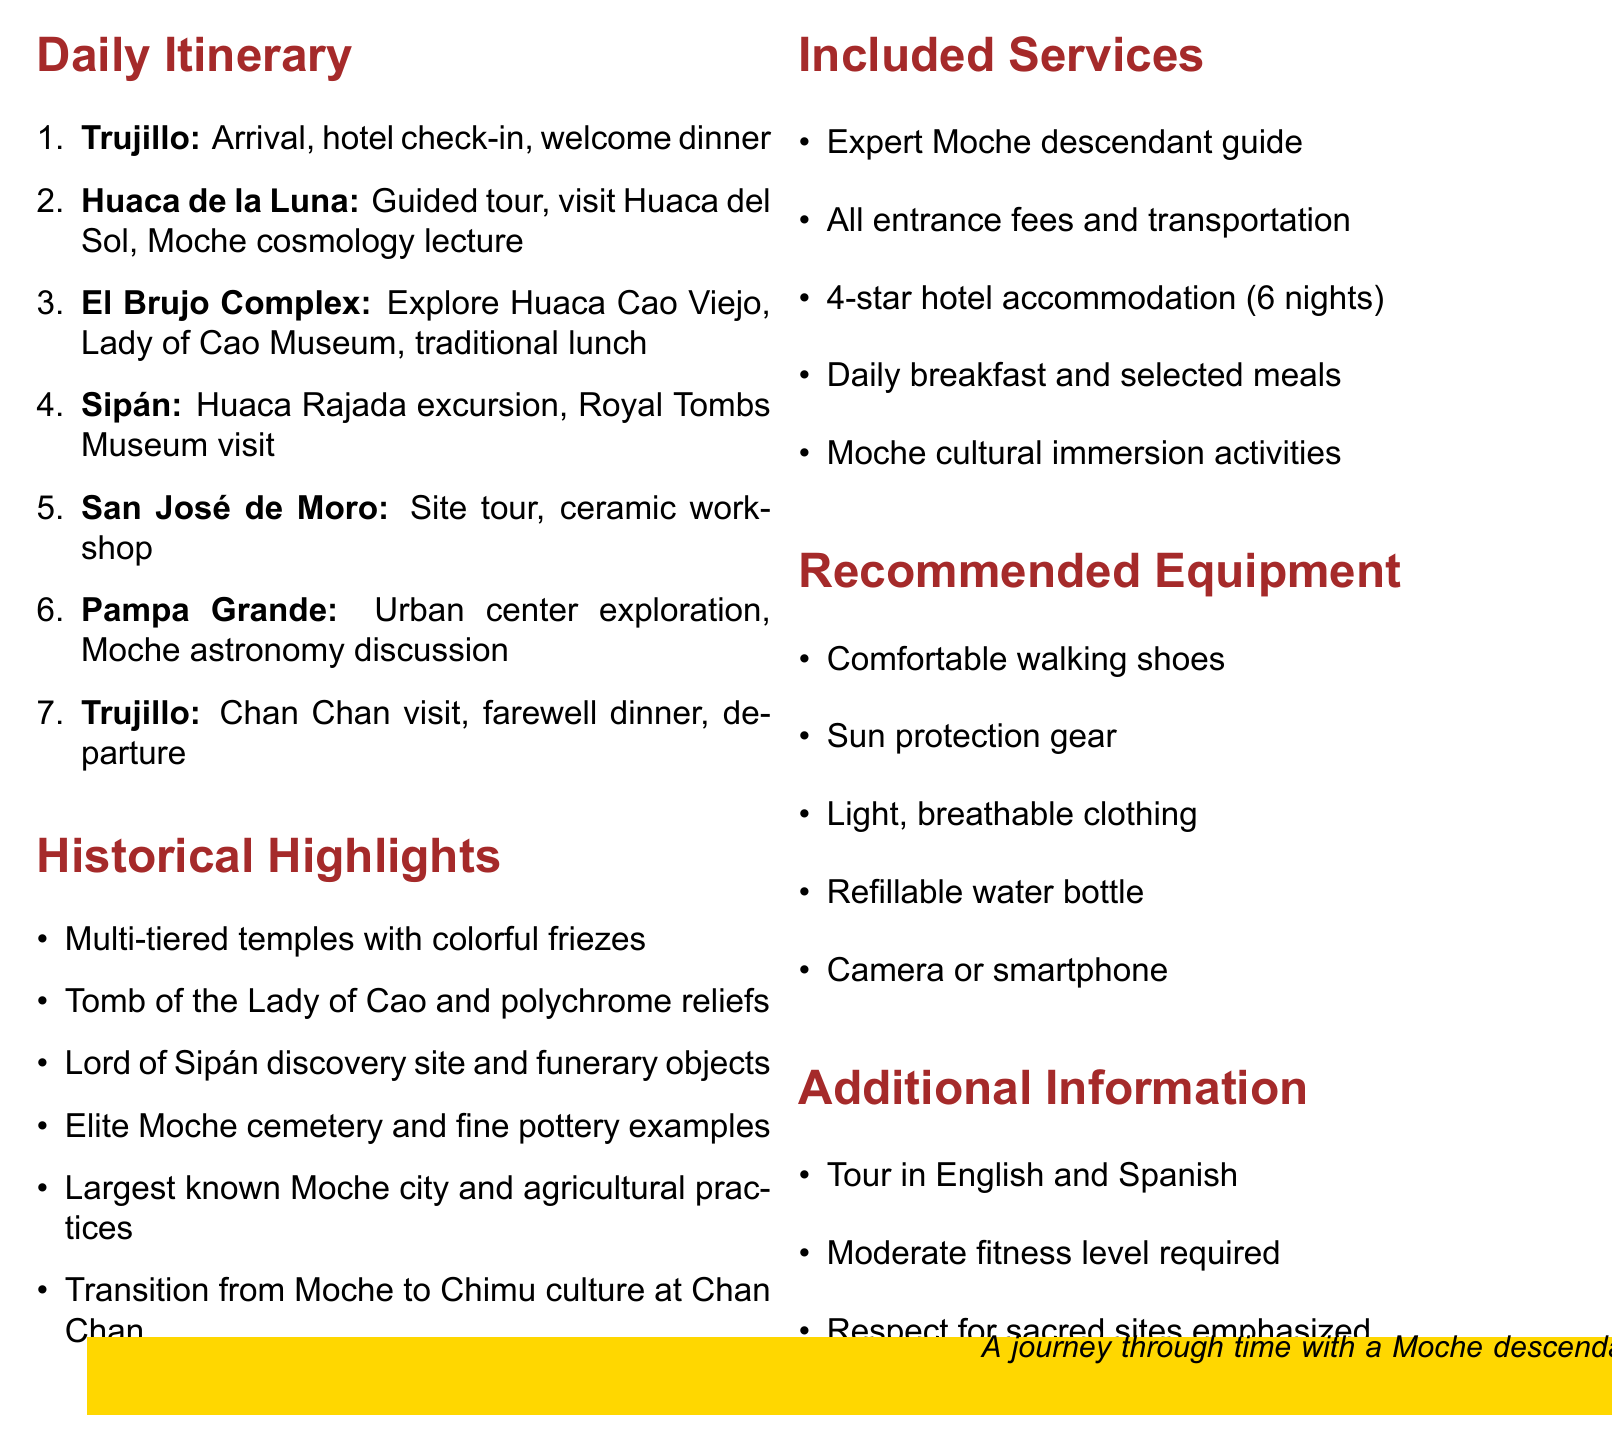What is the name of the tour? The document lists the name of the tour as "Moche Heritage Expedition".
Answer: Moche Heritage Expedition How many days does the tour last? The duration of the tour is explicitly stated in the document, which is 7 days.
Answer: 7 days What is the maximum group size for the expedition? The document specifies that the maximum group size is 12 participants.
Answer: 12 Which archaeological site is visited on Day 2? Day 2 of the itinerary mentions a guided tour of "Huaca de la Luna".
Answer: Huaca de la Luna What type of meal is included on Day 3? The itinerary for Day 3 includes a "Traditional Moche-inspired lunch".
Answer: Traditional Moche-inspired lunch What significant discovery is highlighted at Huaca Rajada? The document highlights the "discovery site of the Lord of Sipán" in relation to Huaca Rajada.
Answer: Lord of Sipán What is one of the historical highlights at Pampa Grande? The document notes that Pampa Grande is recognized as the "Largest known Moche city".
Answer: Largest known Moche city What accommodations are provided during the tour? The document states that there will be "6 nights accommodation in 4-star hotels".
Answer: 4-star hotels What is emphasized regarding respect during the tour? The document mentions that respect for "sacred sites and artifacts" is emphasized throughout the tour.
Answer: Sacred sites and artifacts 